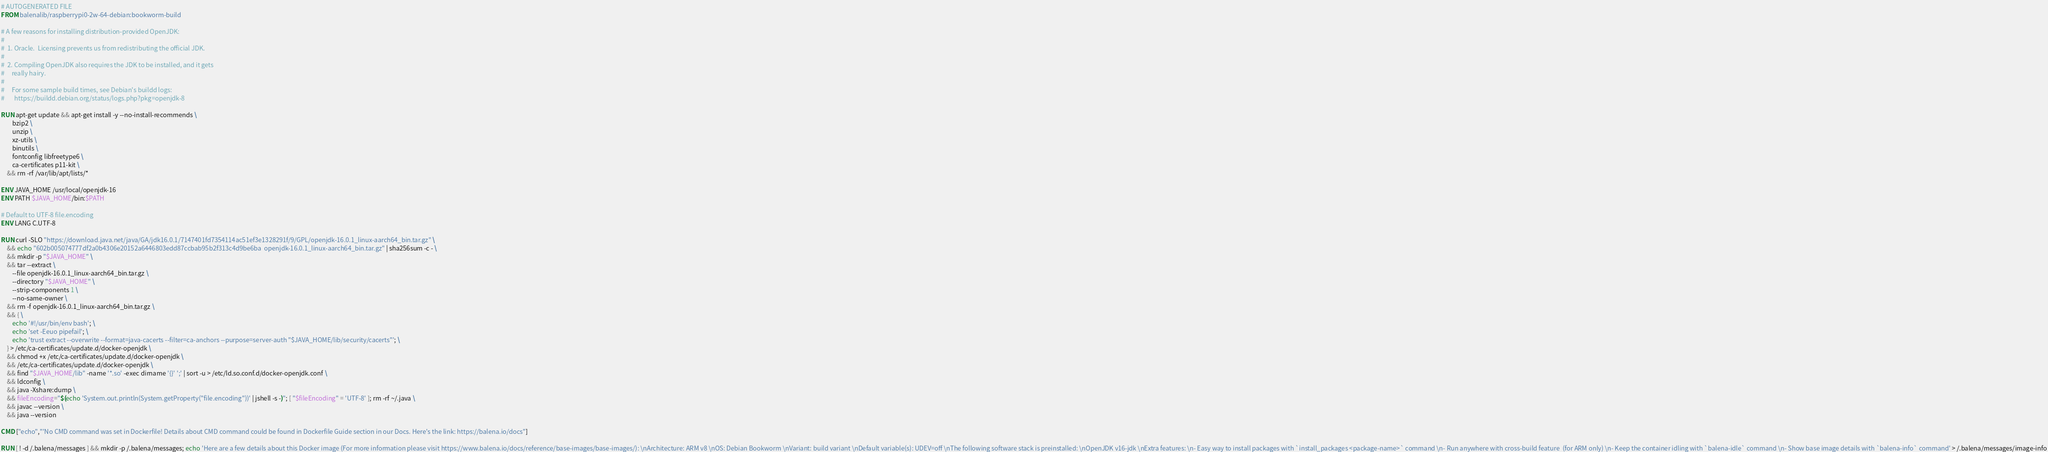<code> <loc_0><loc_0><loc_500><loc_500><_Dockerfile_># AUTOGENERATED FILE
FROM balenalib/raspberrypi0-2w-64-debian:bookworm-build

# A few reasons for installing distribution-provided OpenJDK:
#
#  1. Oracle.  Licensing prevents us from redistributing the official JDK.
#
#  2. Compiling OpenJDK also requires the JDK to be installed, and it gets
#     really hairy.
#
#     For some sample build times, see Debian's buildd logs:
#       https://buildd.debian.org/status/logs.php?pkg=openjdk-8

RUN apt-get update && apt-get install -y --no-install-recommends \
		bzip2 \
		unzip \
		xz-utils \
		binutils \
		fontconfig libfreetype6 \
		ca-certificates p11-kit \
	&& rm -rf /var/lib/apt/lists/*

ENV JAVA_HOME /usr/local/openjdk-16
ENV PATH $JAVA_HOME/bin:$PATH

# Default to UTF-8 file.encoding
ENV LANG C.UTF-8

RUN curl -SLO "https://download.java.net/java/GA/jdk16.0.1/7147401fd7354114ac51ef3e1328291f/9/GPL/openjdk-16.0.1_linux-aarch64_bin.tar.gz" \
	&& echo "602b005074777df2a0b4306e20152a6446803edd87ccbab95b2f313c4d9be6ba  openjdk-16.0.1_linux-aarch64_bin.tar.gz" | sha256sum -c - \
	&& mkdir -p "$JAVA_HOME" \
	&& tar --extract \
		--file openjdk-16.0.1_linux-aarch64_bin.tar.gz \
		--directory "$JAVA_HOME" \
		--strip-components 1 \
		--no-same-owner \
	&& rm -f openjdk-16.0.1_linux-aarch64_bin.tar.gz \
	&& { \
		echo '#!/usr/bin/env bash'; \
		echo 'set -Eeuo pipefail'; \
		echo 'trust extract --overwrite --format=java-cacerts --filter=ca-anchors --purpose=server-auth "$JAVA_HOME/lib/security/cacerts"'; \
	} > /etc/ca-certificates/update.d/docker-openjdk \
	&& chmod +x /etc/ca-certificates/update.d/docker-openjdk \
	&& /etc/ca-certificates/update.d/docker-openjdk \
	&& find "$JAVA_HOME/lib" -name '*.so' -exec dirname '{}' ';' | sort -u > /etc/ld.so.conf.d/docker-openjdk.conf \
	&& ldconfig \
	&& java -Xshare:dump \
	&& fileEncoding="$(echo 'System.out.println(System.getProperty("file.encoding"))' | jshell -s -)"; [ "$fileEncoding" = 'UTF-8' ]; rm -rf ~/.java \
	&& javac --version \
	&& java --version

CMD ["echo","'No CMD command was set in Dockerfile! Details about CMD command could be found in Dockerfile Guide section in our Docs. Here's the link: https://balena.io/docs"]

RUN [ ! -d /.balena/messages ] && mkdir -p /.balena/messages; echo 'Here are a few details about this Docker image (For more information please visit https://www.balena.io/docs/reference/base-images/base-images/): \nArchitecture: ARM v8 \nOS: Debian Bookworm \nVariant: build variant \nDefault variable(s): UDEV=off \nThe following software stack is preinstalled: \nOpenJDK v16-jdk \nExtra features: \n- Easy way to install packages with `install_packages <package-name>` command \n- Run anywhere with cross-build feature  (for ARM only) \n- Keep the container idling with `balena-idle` command \n- Show base image details with `balena-info` command' > /.balena/messages/image-info</code> 